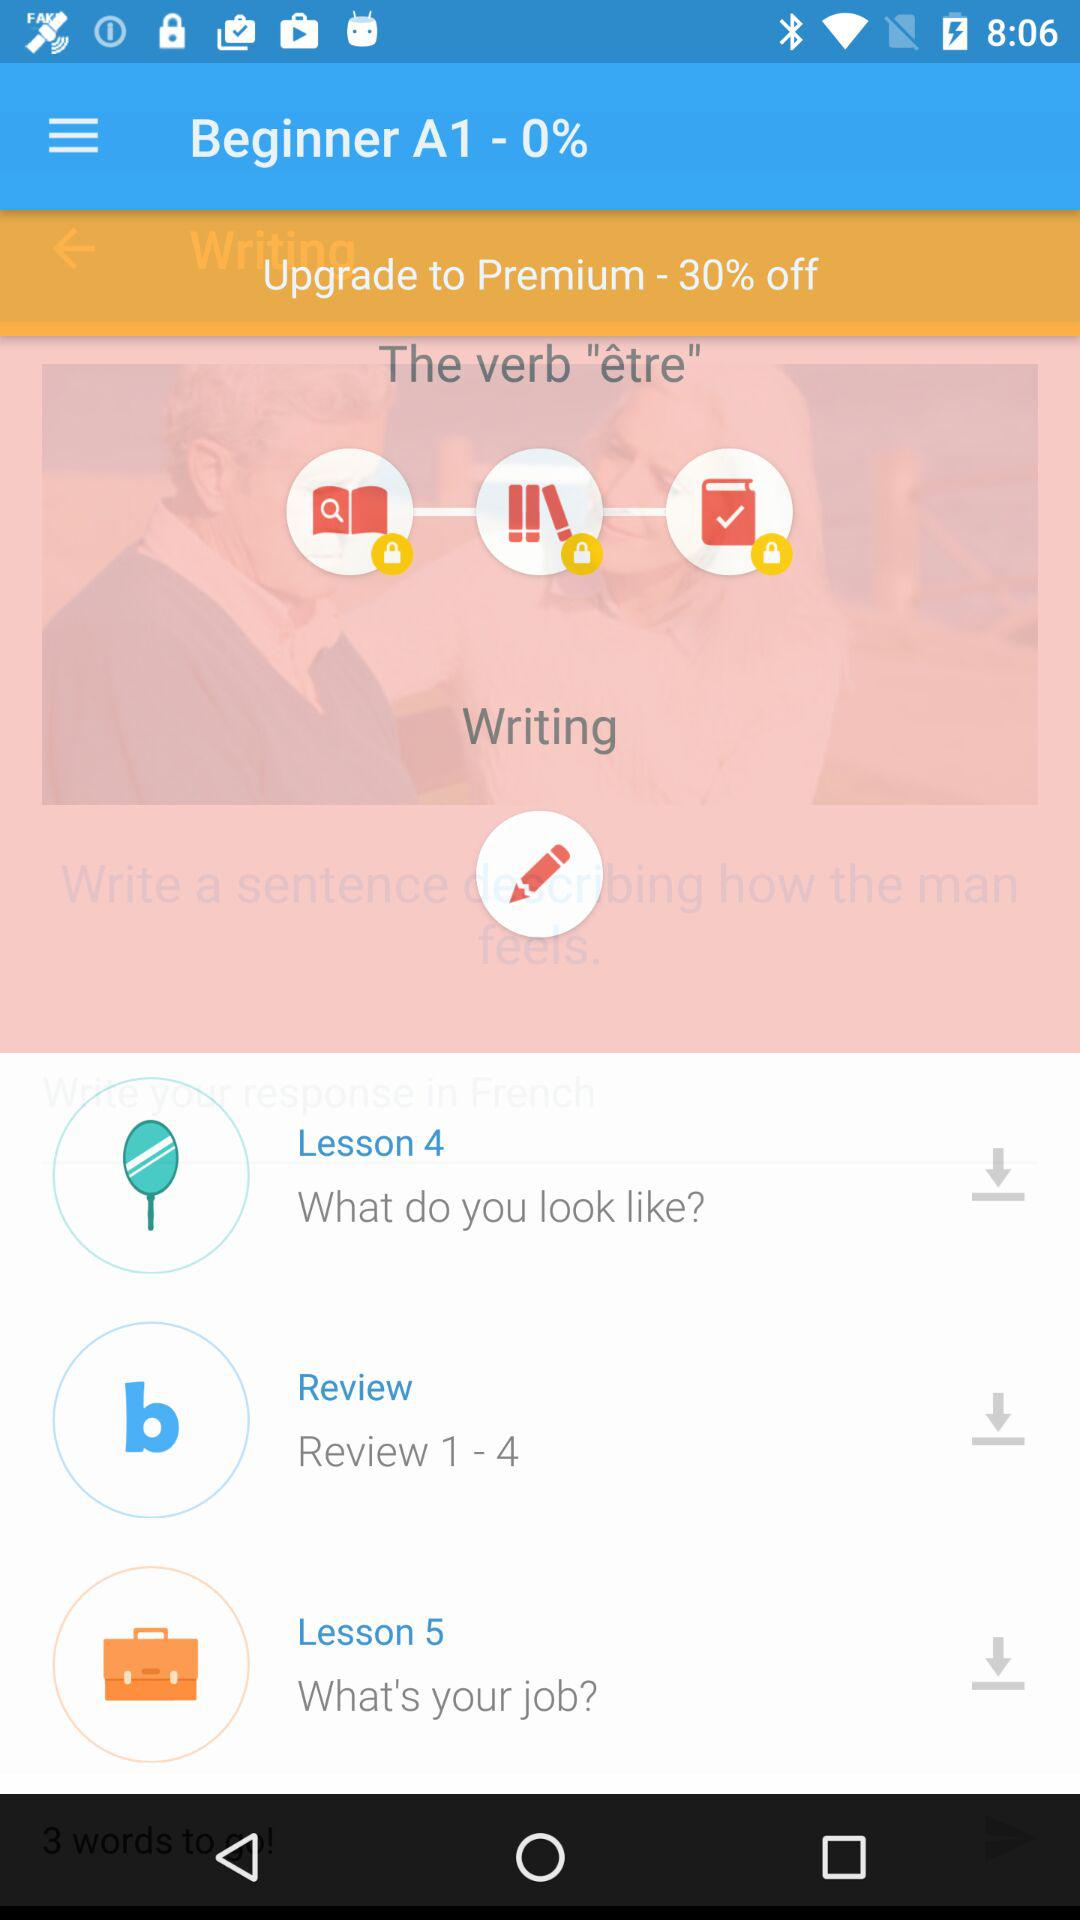How many lessons are there in total?
Answer the question using a single word or phrase. 5 